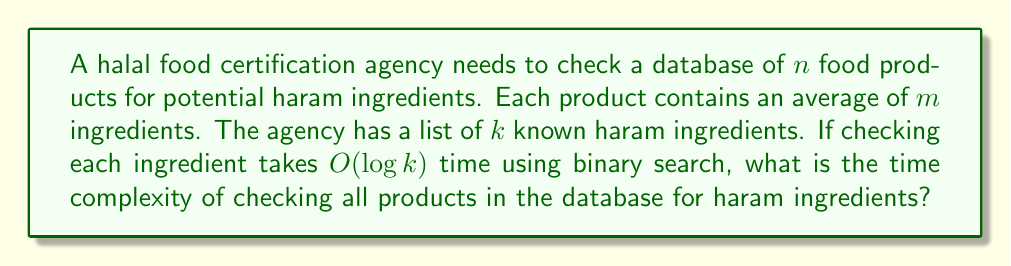Show me your answer to this math problem. To solve this problem, we need to consider the following steps:

1. For each product, we need to check all of its ingredients against the list of haram ingredients.

2. There are $n$ products in the database, and each product has an average of $m$ ingredients.

3. For each ingredient, we perform a binary search on the list of $k$ haram ingredients, which takes $O(\log k)$ time.

4. Therefore, for a single product, we perform $m$ searches, each taking $O(\log k)$ time.

5. The time complexity for checking one product is $O(m \log k)$.

6. We need to repeat this process for all $n$ products in the database.

Thus, the total time complexity is:

$$O(n \cdot m \cdot \log k)$$

This represents the worst-case scenario where we need to check every ingredient of every product against the entire list of haram ingredients.
Answer: $O(n \cdot m \cdot \log k)$ 